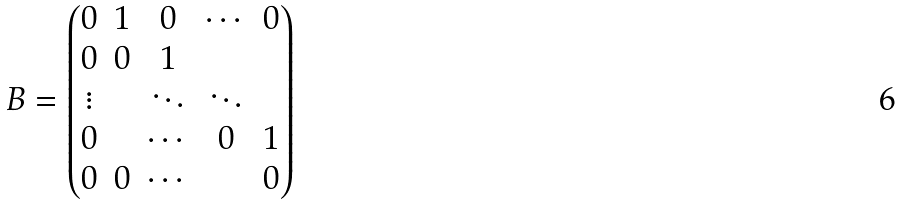Convert formula to latex. <formula><loc_0><loc_0><loc_500><loc_500>B = \left ( \begin{matrix} 0 & 1 & 0 & \cdots & 0 \\ 0 & 0 & 1 \\ \vdots & & \ddots & \ddots \\ 0 & & \cdots & 0 & 1 \\ 0 & 0 & \cdots & & 0 \end{matrix} \right )</formula> 